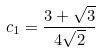Convert formula to latex. <formula><loc_0><loc_0><loc_500><loc_500>c _ { 1 } = \frac { 3 + \sqrt { 3 } } { 4 \sqrt { 2 } }</formula> 